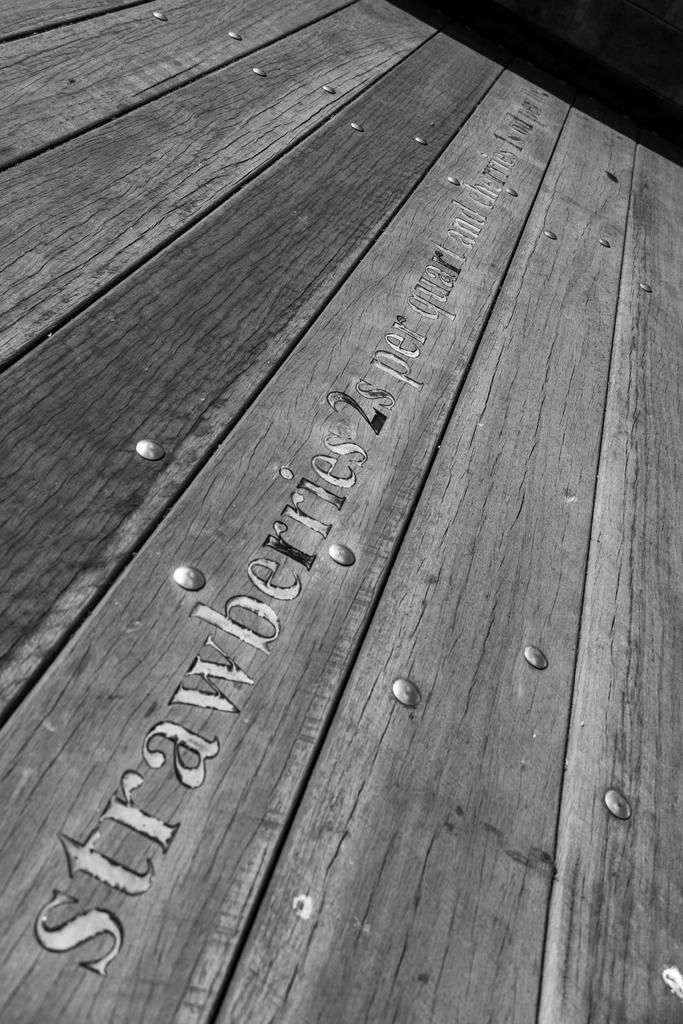<image>
Give a short and clear explanation of the subsequent image. A pciture of a wooden surface that is labeled strawberries. 